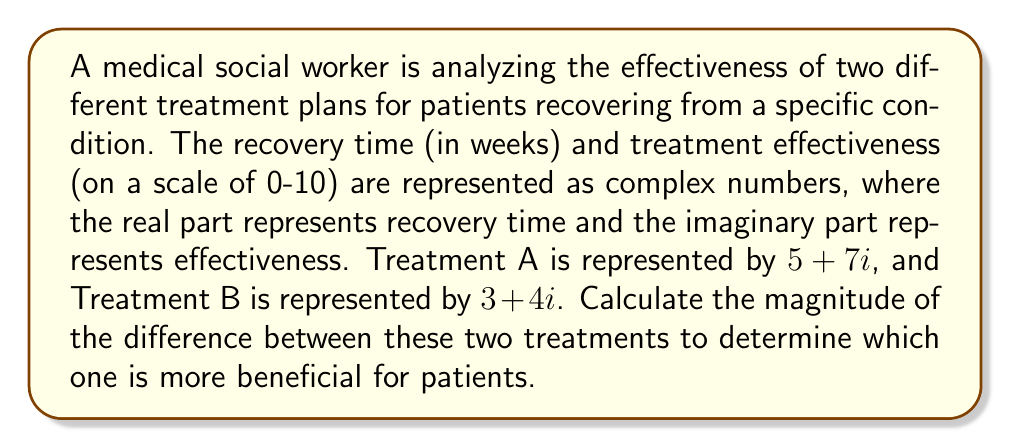Solve this math problem. To solve this problem, we need to follow these steps:

1) First, let's identify the complex numbers:
   Treatment A: $z_1 = 5 + 7i$
   Treatment B: $z_2 = 3 + 4i$

2) To find the difference between these treatments, we subtract $z_2$ from $z_1$:
   $z = z_1 - z_2 = (5 + 7i) - (3 + 4i) = (5 - 3) + (7 - 4)i = 2 + 3i$

3) Now, we need to calculate the magnitude of this difference. The magnitude of a complex number $a + bi$ is given by the formula:
   $|a + bi| = \sqrt{a^2 + b^2}$

4) In this case, $a = 2$ and $b = 3$, so:
   $|z| = |2 + 3i| = \sqrt{2^2 + 3^2} = \sqrt{4 + 9} = \sqrt{13}$

5) $\sqrt{13} \approx 3.61$ (rounded to two decimal places)

This magnitude represents the overall difference between the two treatments in terms of both recovery time and effectiveness. A larger magnitude indicates a more significant difference between the treatments.

In this case, the magnitude of 3.61 suggests a notable difference between Treatment A and Treatment B. Treatment A has a longer recovery time (5 weeks vs 3 weeks) but higher effectiveness (7 vs 4). The medical social worker should consider this information when developing comprehensive care plans, potentially recommending Treatment A for patients who prioritize effectiveness over a shorter recovery time, or Treatment B for those who need a quicker recovery.
Answer: $\sqrt{13}$ 